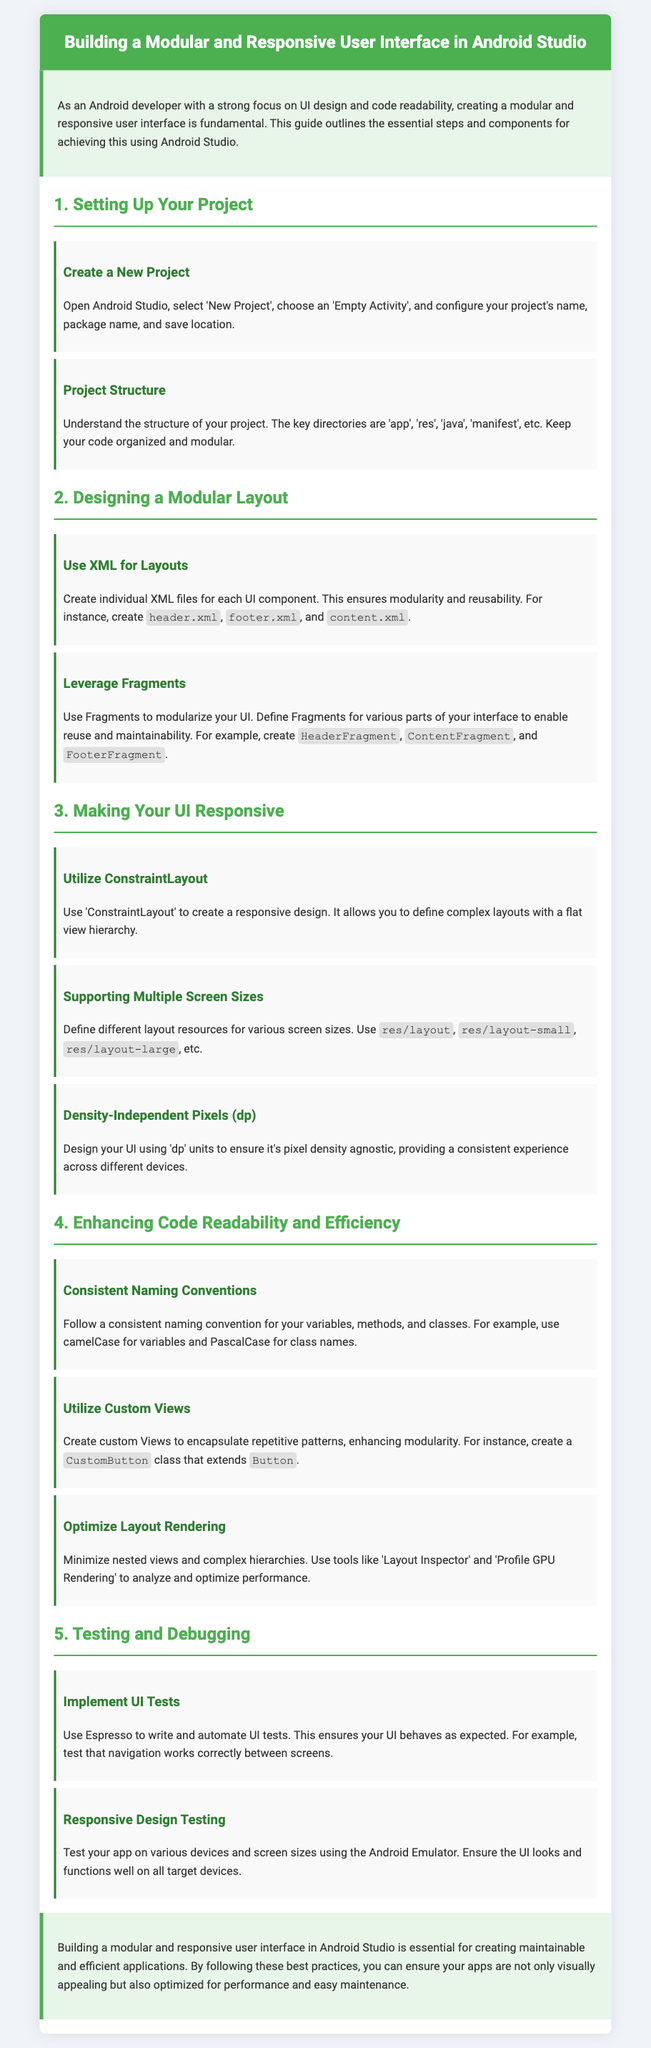What is the title of the document? The title is prominently displayed in the header section of the document and states the main focus of the content.
Answer: Building a Modular and Responsive User Interface in Android Studio What is the primary color used in the header? The header section of the document has a specific background color that is referred to in the style.
Answer: Green What layout is recommended for a responsive design? The document outlines a specific layout that is effective for creating a flexible and adaptive UI.
Answer: ConstraintLayout What should be used for modular layout design? The instructions specify a technology used in Android development for creating reusable UI components.
Answer: XML Which testing framework is mentioned for implementing UI tests? The document highlights a specific testing tool for automating user interface tests in Android applications.
Answer: Espresso How many sections are there in the document? The sections are clearly numbered in the content, providing a total count for the reader.
Answer: Five What naming convention should be followed for class names? The guidelines in the document suggest a particular format for naming classes in code.
Answer: PascalCase What resources should be defined for different screen sizes? The content outlines various directory names that should be used to accommodate different device sizes.
Answer: layout, layout-small, layout-large What is suggested for optimizing layout rendering? The document discusses a technique to enhance performance by minimizing view complexity.
Answer: Minimize nested views 